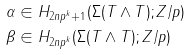Convert formula to latex. <formula><loc_0><loc_0><loc_500><loc_500>\alpha & \in H _ { 2 n p ^ { k } + 1 } ( \Sigma ( T \wedge T ) ; Z / p ) \\ \beta & \in H _ { 2 n p ^ { k } } ( \Sigma ( T \wedge T ) ; Z / p )</formula> 